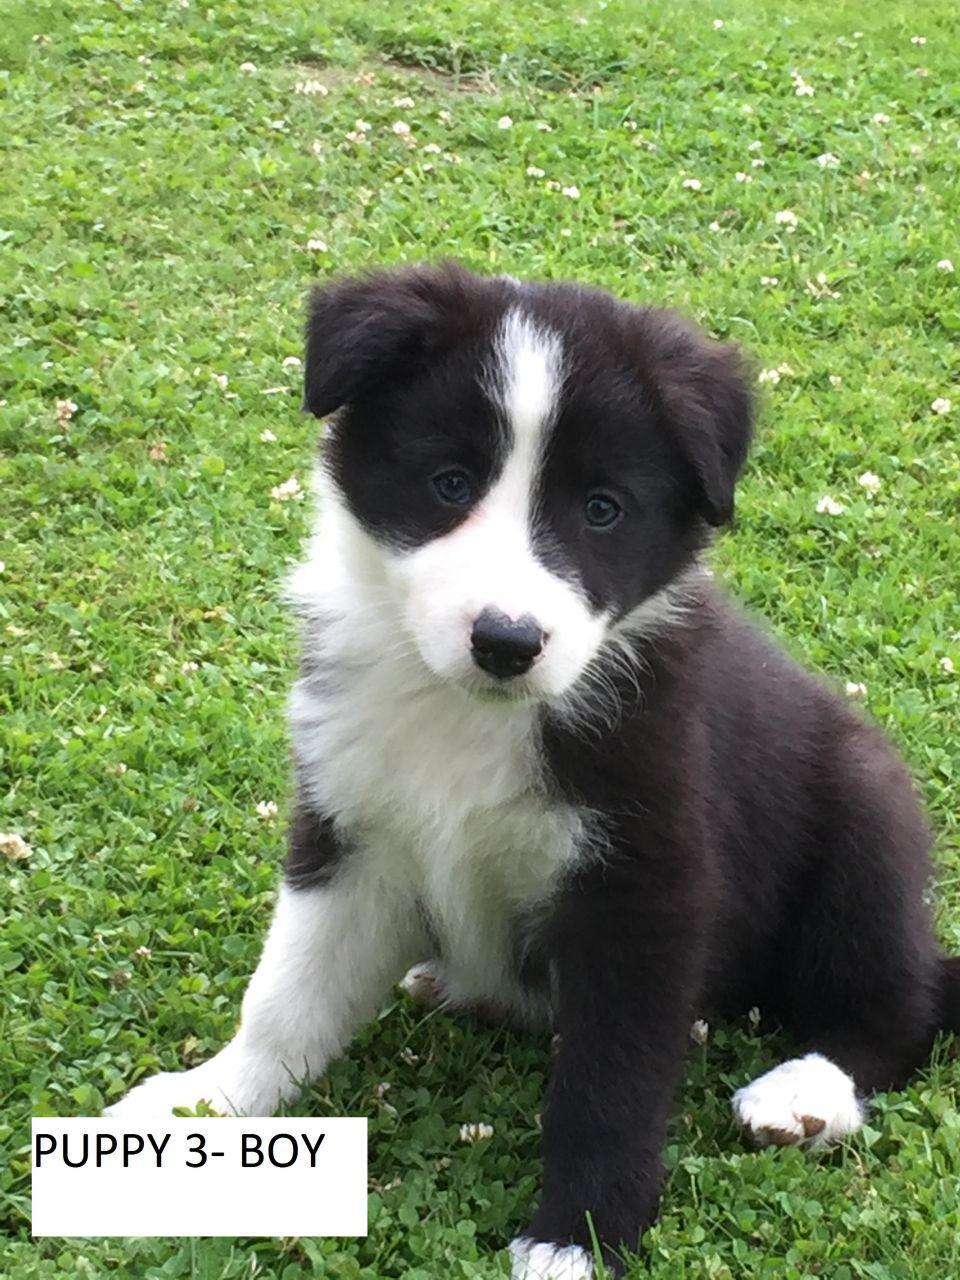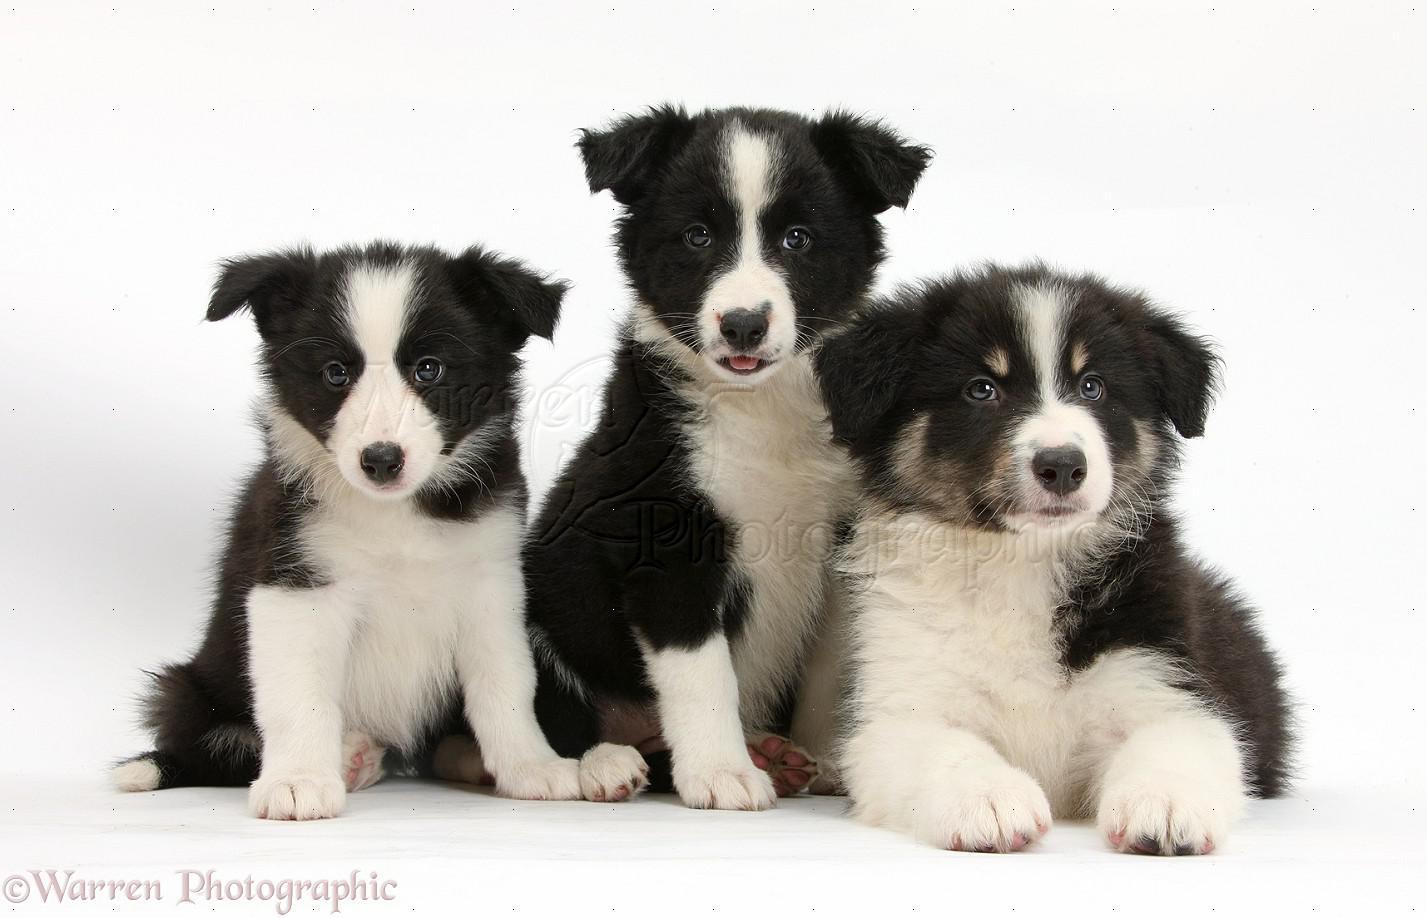The first image is the image on the left, the second image is the image on the right. For the images shown, is this caption "There are four puppies in the pair of images." true? Answer yes or no. Yes. The first image is the image on the left, the second image is the image on the right. Analyze the images presented: Is the assertion "Both images contain only one dog." valid? Answer yes or no. No. 